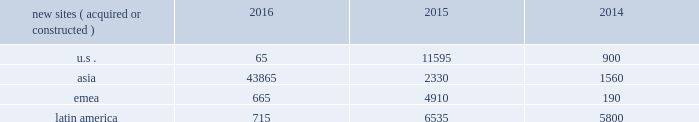In emerging markets , such as ghana , india , nigeria and uganda , wireless networks tend to be significantly less advanced than those in the united states , and initial voice networks continue to be deployed in underdeveloped areas .
A majority of consumers in these markets still utilize basic wireless services , predominantly on feature phones , while advanced device penetration remains low .
In more developed urban locations within these markets , early-stage data network deployments are underway .
Carriers are focused on completing voice network build-outs while also investing in initial data networks as wireless data usage and smartphone penetration within their customer bases begin to accelerate .
In markets with rapidly evolving network technology , such as south africa and most of the countries in latin america where we do business , initial voice networks , for the most part , have already been built out , and carriers are focused on 3g and 4g network build outs .
Consumers in these regions are increasingly adopting smartphones and other advanced devices , and , as a result , the usage of bandwidth-intensive mobile applications is growing materially .
Recent spectrum auctions in these rapidly evolving markets have allowed incumbent carriers to accelerate their data network deployments and have also enabled new entrants to begin initial investments in data networks .
Smartphone penetration and wireless data usage in these markets are growing rapidly , which typically requires that carriers continue to invest in their networks in order to maintain and augment their quality of service .
Finally , in markets with more mature network technology , such as germany and france , carriers are focused on deploying 4g data networks to account for rapidly increasing wireless data usage among their customer base .
With higher smartphone and advanced device penetration and significantly higher per capita data usage , carrier investment in networks is focused on 4g coverage and capacity .
We believe that the network technology migration we have seen in the united states , which has led to significantly denser networks and meaningful new business commencements for us over a number of years , will ultimately be replicated in our less advanced international markets .
As a result , we expect to be able to leverage our extensive international portfolio of approximately 104470 communications sites and the relationships we have built with our carrier customers to drive sustainable , long-term growth .
We have master lease agreements with certain of our tenants that provide for consistent , long-term revenue and reduce the likelihood of churn .
Our master lease agreements build and augment strong strategic partnerships with our tenants and have significantly reduced colocation cycle times , thereby providing our tenants with the ability to rapidly and efficiently deploy equipment on our sites .
Property operations new site revenue growth .
During the year ended december 31 , 2016 , we grew our portfolio of communications real estate through the acquisition and construction of approximately 45310 sites .
In a majority of our asia , emea and latin america markets , the revenue generated from newly acquired or constructed sites resulted in increases in both tenant and pass-through revenues ( such as ground rent or power and fuel costs ) and expenses .
We continue to evaluate opportunities to acquire communications real estate portfolios , both domestically and internationally , to determine whether they meet our risk-adjusted hurdle rates and whether we believe we can effectively integrate them into our existing portfolio. .
Property operations expenses .
Direct operating expenses incurred by our property segments include direct site level expenses and consist primarily of ground rent and power and fuel costs , some or all of which may be passed through to our tenants , as well as property taxes , repairs and maintenance .
These segment direct operating expenses exclude all segment and corporate selling , general , administrative and development expenses , which are aggregated into one line item entitled selling , general , administrative and development expense in our consolidated statements of operations .
In general , our property segments 2019 selling , general , administrative and development expenses do not significantly increase as a result of adding incremental tenants to our sites and typically increase only modestly year-over-year .
As a result , leasing additional space to new tenants on our sites provides significant incremental cash flow .
We may , however , incur additional segment selling , general , administrative and development expenses as we increase our presence in our existing markets or expand into new markets .
Our profit margin growth is therefore positively impacted by the addition of new tenants to our sites but can be temporarily diluted by our development activities. .
What was the ratio of the growth of the communications real estate portfoliosfor the emea to us in 2016? 
Computations: (665 / 65)
Answer: 10.23077. 